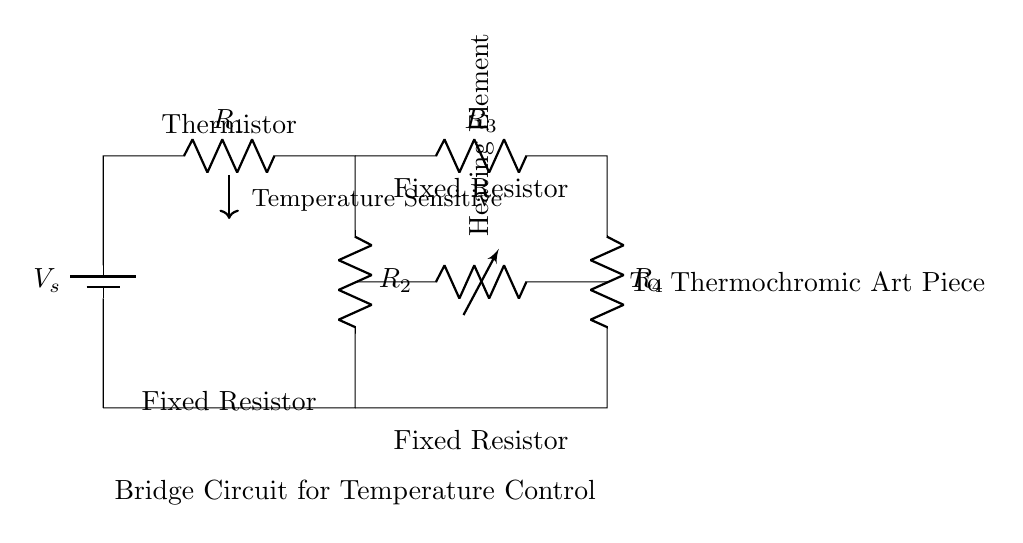What is the controlling component in this circuit? The controlling component is the thermistor, as it measures temperature and affects the heating element's operation based on temperature changes.
Answer: thermistor How many fixed resistors are present in the circuit? There are three fixed resistors connected in the bridge configuration, which balances the circuit and influences the circuit's response to temperature.
Answer: three What does the heating element do in this circuit? The heating element is designed to produce heat when activated by the control signal from the thermistor, facilitating the temperature-sensitive effect in the art piece.
Answer: produces heat Which components form the bridge structure? The bridge structure comprises four resistors (R1, R2, R3, R4) in a specific arrangement that allows for balanced measurement and control of temperature-induced changes within the circuit.
Answer: R1, R2, R3, R4 What is the purpose of the battery in this circuit? The battery provides the necessary voltage supply to drive the current through the circuit components, enabling the system to function properly and control the heating element.
Answer: voltage supply 